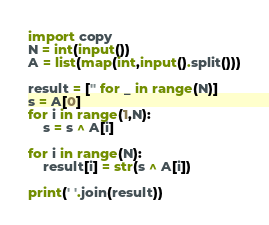Convert code to text. <code><loc_0><loc_0><loc_500><loc_500><_Python_>import copy
N = int(input())
A = list(map(int,input().split()))

result = ['' for _ in range(N)]
s = A[0]
for i in range(1,N):
    s = s ^ A[i]

for i in range(N):
    result[i] = str(s ^ A[i])

print(' '.join(result)) </code> 